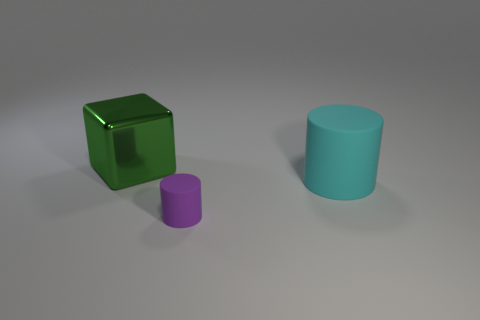Add 2 matte cylinders. How many objects exist? 5 Subtract 0 blue cubes. How many objects are left? 3 Subtract all cylinders. How many objects are left? 1 Subtract all blue cubes. Subtract all cyan things. How many objects are left? 2 Add 1 large things. How many large things are left? 3 Add 1 purple rubber things. How many purple rubber things exist? 2 